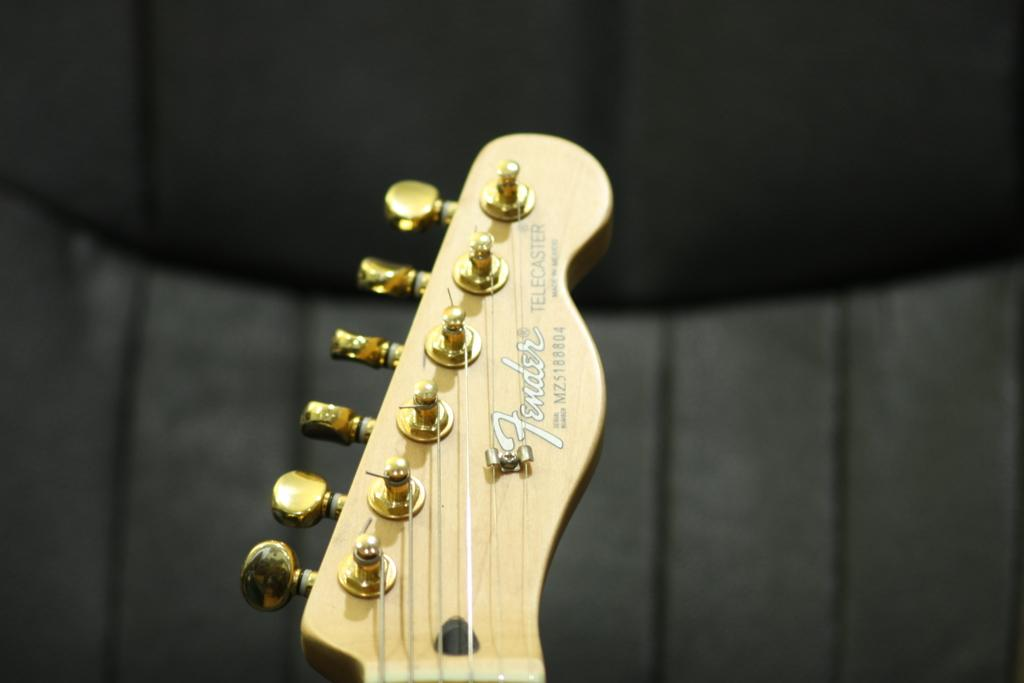What musical instrument part is visible in the image? The image contains a guitar head. What is the primary function of the guitar head? The guitar head is used to tune the strings of the guitar. Are there any other parts of the guitar visible in the image? The provided facts do not mention any other parts of the guitar being visible. What type of silk material is used to make the brake pads in the image? There is no mention of silk or brake pads in the image; it contains a guitar head. 